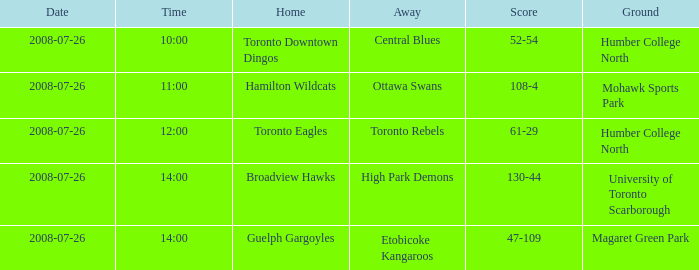Who has the Home Score of 52-54? Toronto Downtown Dingos. 